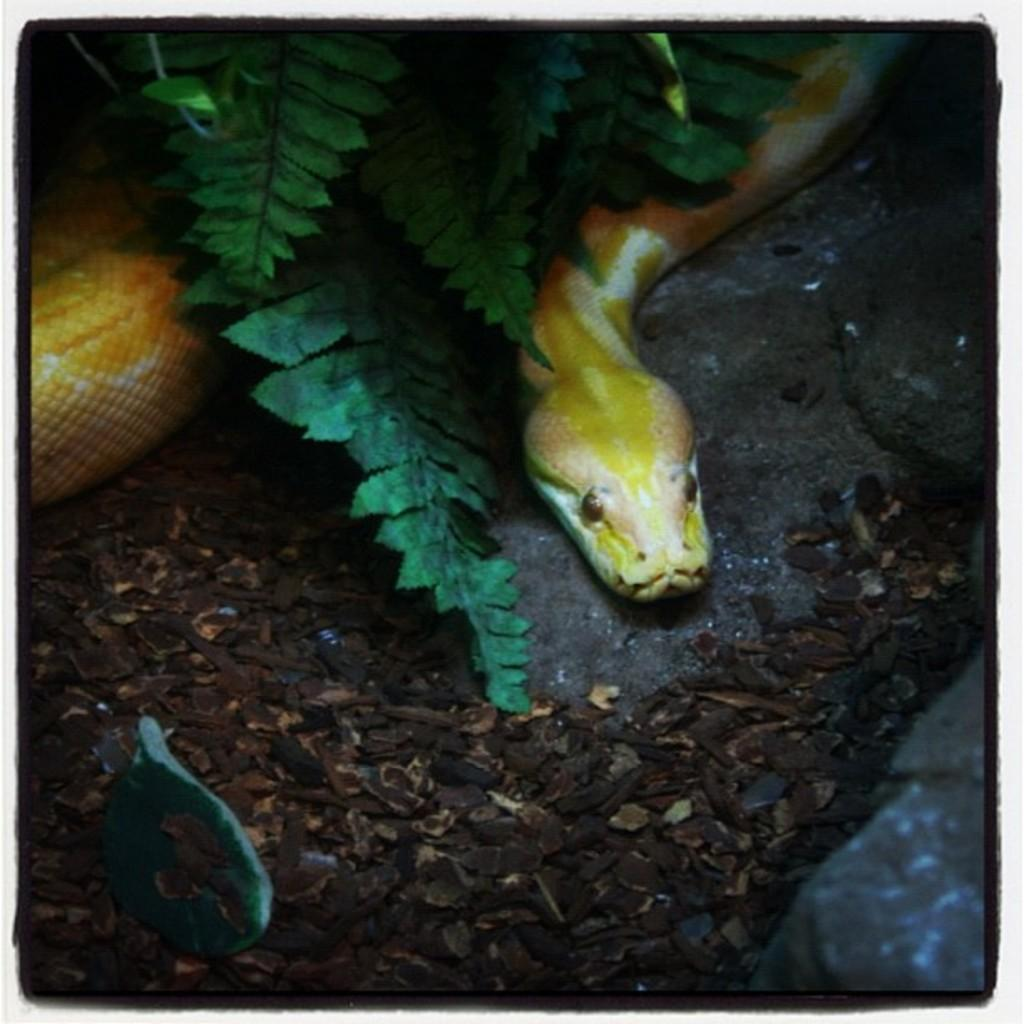What animal is present in the image? There is a snake in the image. Where is the snake located? The snake is on the floor. What type of vegetation can be seen in the image? There are green color leaves in the image. What type of straw is being used by the snake in the image? There is no straw present in the image; it features a snake on the floor and green color leaves. 